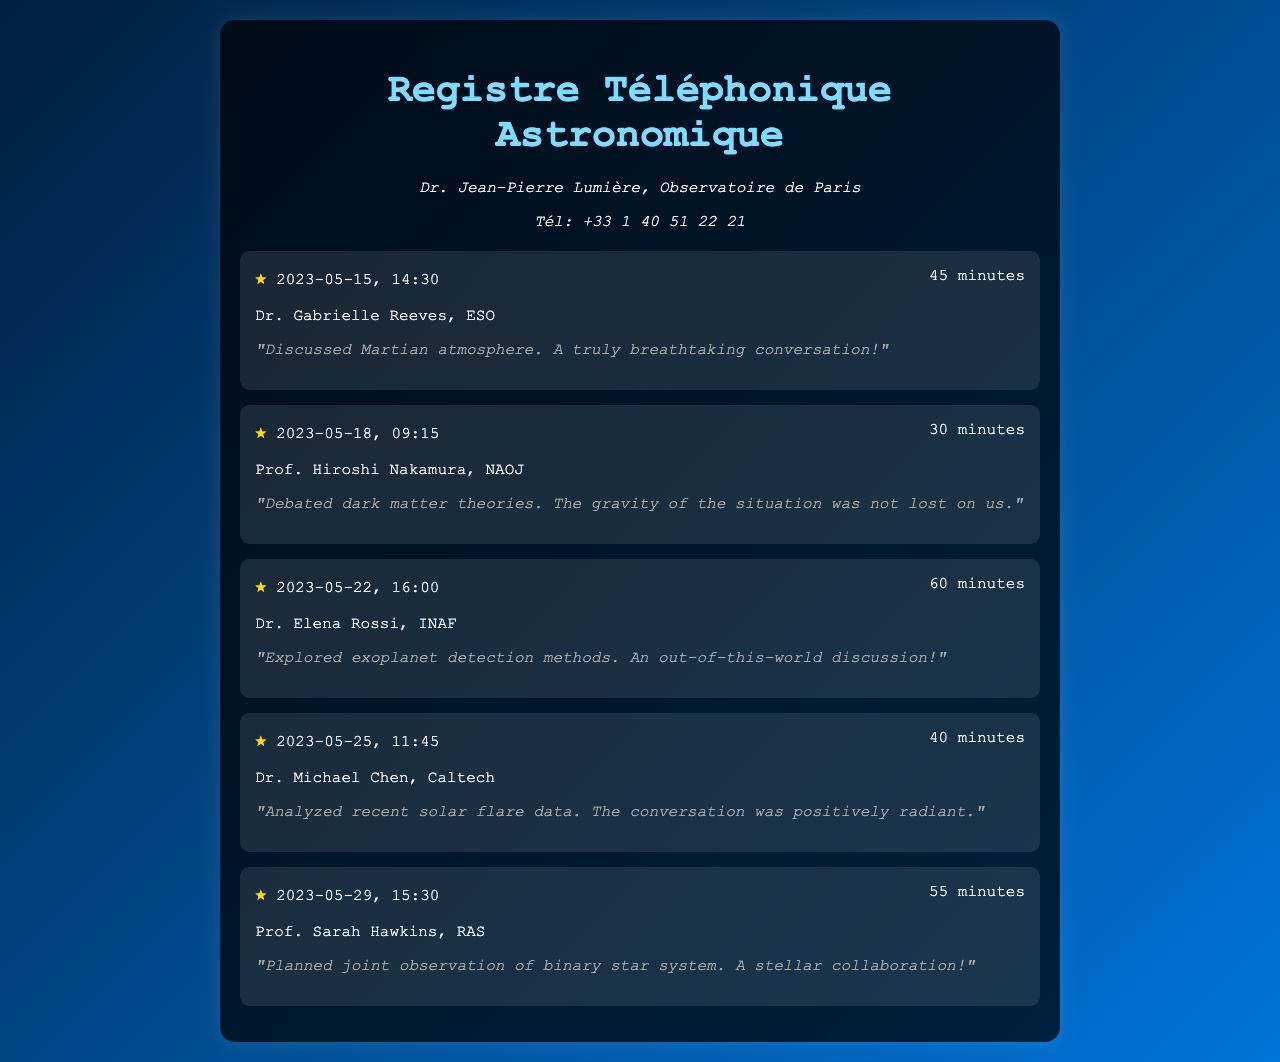Quel est le nom du premier interlocuteur ? Le premier interlocuteur dans le registre est Dr. Gabrielle Reeves.
Answer: Dr. Gabrielle Reeves Combien de minutes dure l'appel avec Prof. Hiroshi Nakamura ? La durée de l'appel avec Prof. Hiroshi Nakamura est mentionnée dans le registre comme 30 minutes.
Answer: 30 minutes Quelle est la date de l'appel concernant l'exploration des méthodes de détection d'exoplanètes ? La date de cet appel est indiquée comme le 22 mai 2023.
Answer: 2023-05-22 Qui a participé à la discussion sur les données des éruptions solaires ? Dr. Michael Chen a participé à cette discussion sur les données des éruptions solaires.
Answer: Dr. Michael Chen Quel est le temps total d'appel concernant la collaboration sur le système stellaire binaire ? Le temps d'appel pour cette collaboration est de 55 minutes.
Answer: 55 minutes Quel thème a été discuté dans l'appel du 15 mai 2023 ? Le thème de l'appel du 15 mai 2023 était l'atmosphère martienne.
Answer: Atmosphère martienne Combien d'appels impliquent des discussions sur des méthodes de détection d'exoplanètes ? Il y a un appel qui traite spécifiquement des méthodes de détection d'exoplanètes.
Answer: Un appel Quel type de collaboration a été prévue lors de l'appel avec Prof. Sarah Hawkins ? Une collaboration d'observation conjointe a été prévue lors de cet appel.
Answer: Observation conjointe Quel adjectif est utilisé pour décrire la discussion sur les méthodes de détection d'exoplanètes ? La discussion a été décrite comme "hors de ce monde."
Answer: Hors de ce monde 